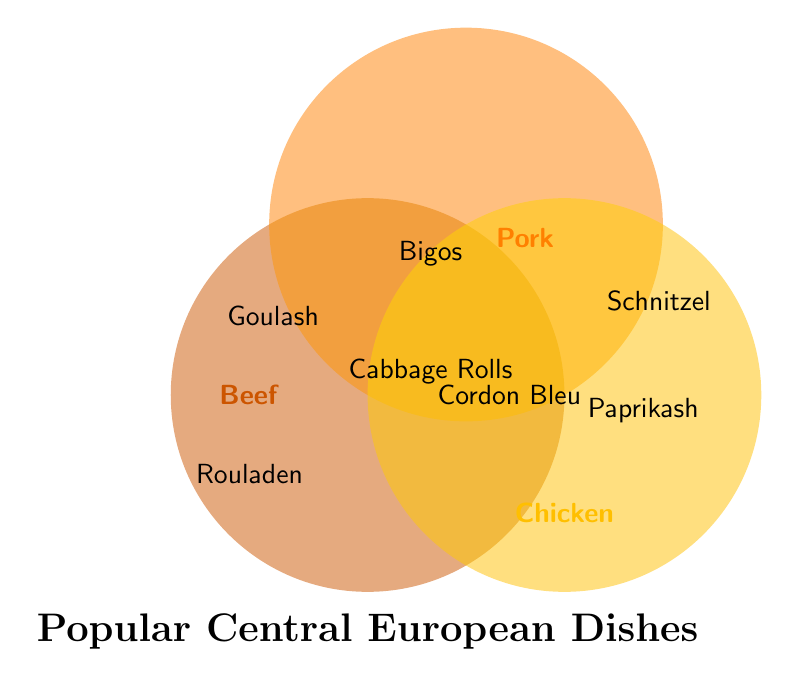Which dish is found only in the Beef category? The only dish located within the circle labeled "Beef" that does not intersect with any other circles is Goulash.
Answer: Goulash What are the three categories intersecting with Cabbage Rolls? The Cabbage Rolls dish is located in the central intersection of all three circles, meaning it intersects with Beef, Pork, and Chicken categories.
Answer: Beef, Pork, Chicken Which dish is found only in the Pork category? The dish in the Pork labeled circle that does not intersect with any other circles is Schnitzel.
Answer: Schnitzel Which dishes appear in both the Beef and Pork intersection? Locating the intersection of the Beef and Pork circles, we see two dishes labeled: Szegedin Goulash and Bigos.
Answer: Szegedin Goulash, Bigos How many dishes contain Beef as a protein source? The dishes in the Beef circle include Goulash, Rouladen, Beef Stroganoff, Szegedin Goulash, Bigos, and Cabbage Rolls, totaling six dishes.
Answer: Six Which dish includes all three proteins: Beef, Pork, and Chicken? The Cabbage Rolls are listed in the center where all three circles intersect, indicating it includes Beef, Pork, and Chicken.
Answer: Cabbage Rolls How many dishes are strictly in one protein category and not in any intersection? There are Goulash, Rouladen, Beef Stroganoff for Beef; Schnitzel, Schweinshaxe, Koleno for Pork; and Paprikash, Chicken Schnitzel, Kurací Rezeň for Chicken. Three dishes per category, totaling nine.
Answer: Nine What is the title of the figure? The title is typically located at the top or in a prominent place. In this Venn Diagram, it is located at the bottom center. The title reads "Popular Central European Dishes".
Answer: Popular Central European Dishes 